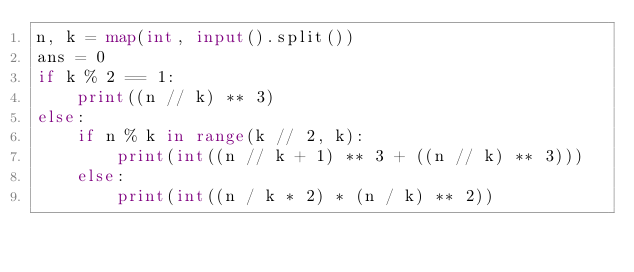Convert code to text. <code><loc_0><loc_0><loc_500><loc_500><_Python_>n, k = map(int, input().split())
ans = 0
if k % 2 == 1:
    print((n // k) ** 3)
else:
    if n % k in range(k // 2, k):
        print(int((n // k + 1) ** 3 + ((n // k) ** 3)))
    else:
        print(int((n / k * 2) * (n / k) ** 2))</code> 